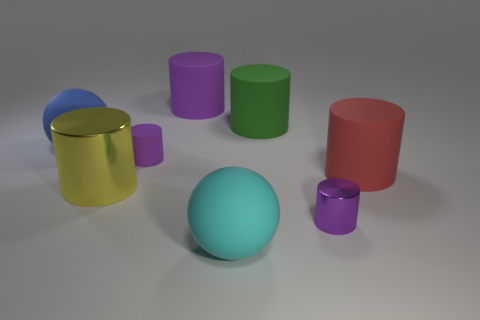What is the material of the green cylinder?
Your response must be concise. Rubber. There is a ball in front of the big sphere that is behind the small cylinder that is behind the large red thing; what is its size?
Keep it short and to the point. Large. There is another tiny cylinder that is the same color as the tiny matte cylinder; what is it made of?
Your answer should be compact. Metal. What number of matte things are either blue spheres or tiny red balls?
Your response must be concise. 1. What size is the green object?
Offer a terse response. Large. What number of things are large yellow metallic cylinders or things in front of the red matte object?
Your response must be concise. 3. What number of other things are the same color as the small metal cylinder?
Offer a very short reply. 2. There is a blue ball; is it the same size as the purple cylinder that is in front of the large yellow metal thing?
Your answer should be very brief. No. Does the purple matte thing behind the blue ball have the same size as the green thing?
Keep it short and to the point. Yes. How many other objects are there of the same material as the big red object?
Make the answer very short. 5. 